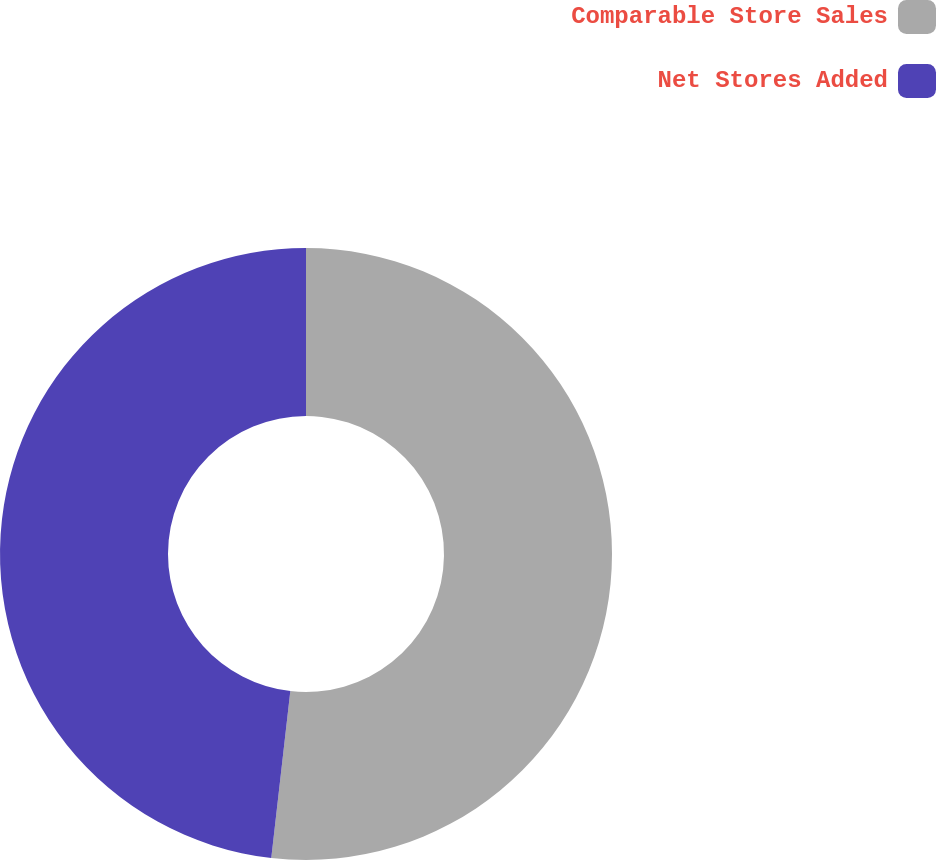<chart> <loc_0><loc_0><loc_500><loc_500><pie_chart><fcel>Comparable Store Sales<fcel>Net Stores Added<nl><fcel>51.81%<fcel>48.19%<nl></chart> 